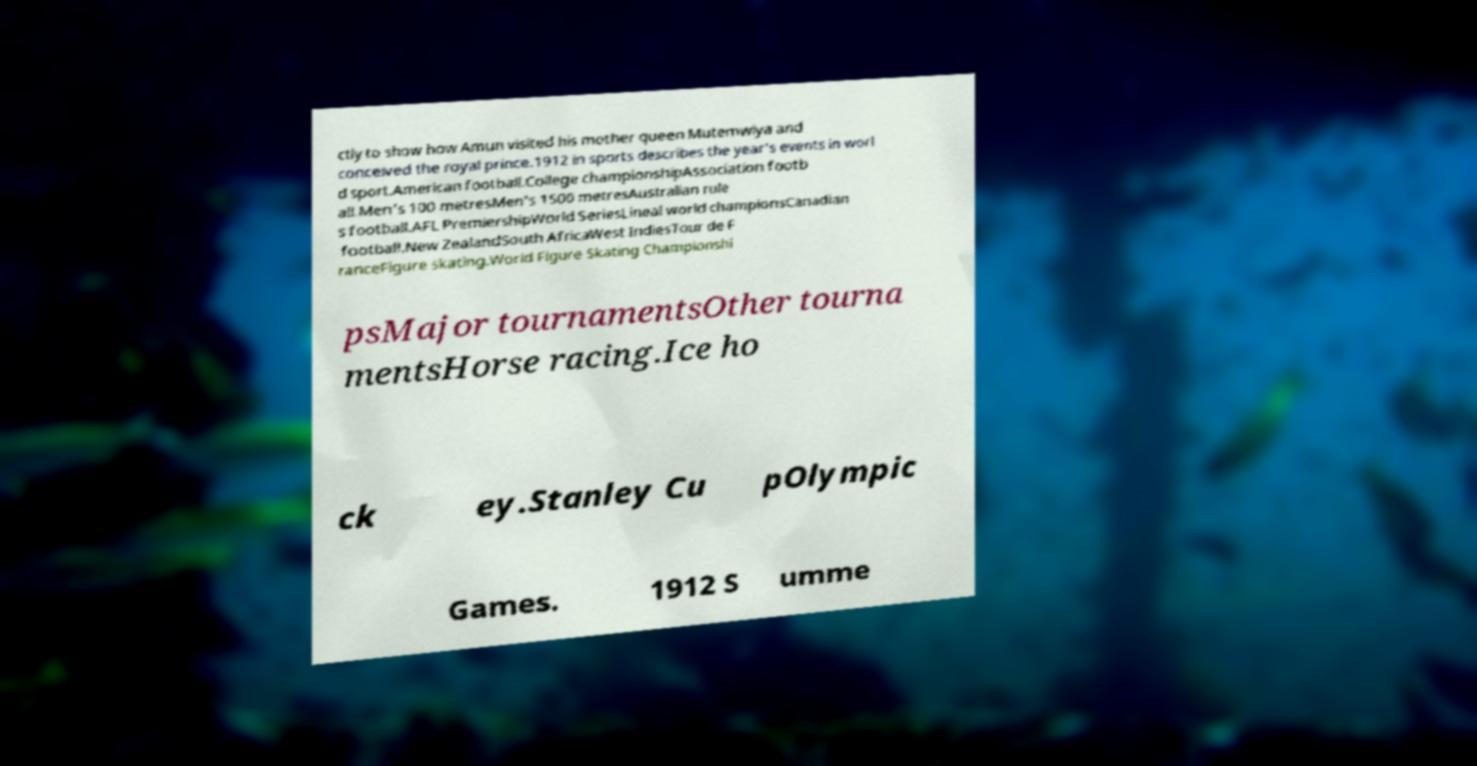Could you assist in decoding the text presented in this image and type it out clearly? ctly to show how Amun visited his mother queen Mutemwiya and conceived the royal prince.1912 in sports describes the year's events in worl d sport.American football.College championshipAssociation footb all.Men's 100 metresMen's 1500 metresAustralian rule s football.AFL PremiershipWorld SeriesLineal world championsCanadian football.New ZealandSouth AfricaWest IndiesTour de F ranceFigure skating.World Figure Skating Championshi psMajor tournamentsOther tourna mentsHorse racing.Ice ho ck ey.Stanley Cu pOlympic Games. 1912 S umme 